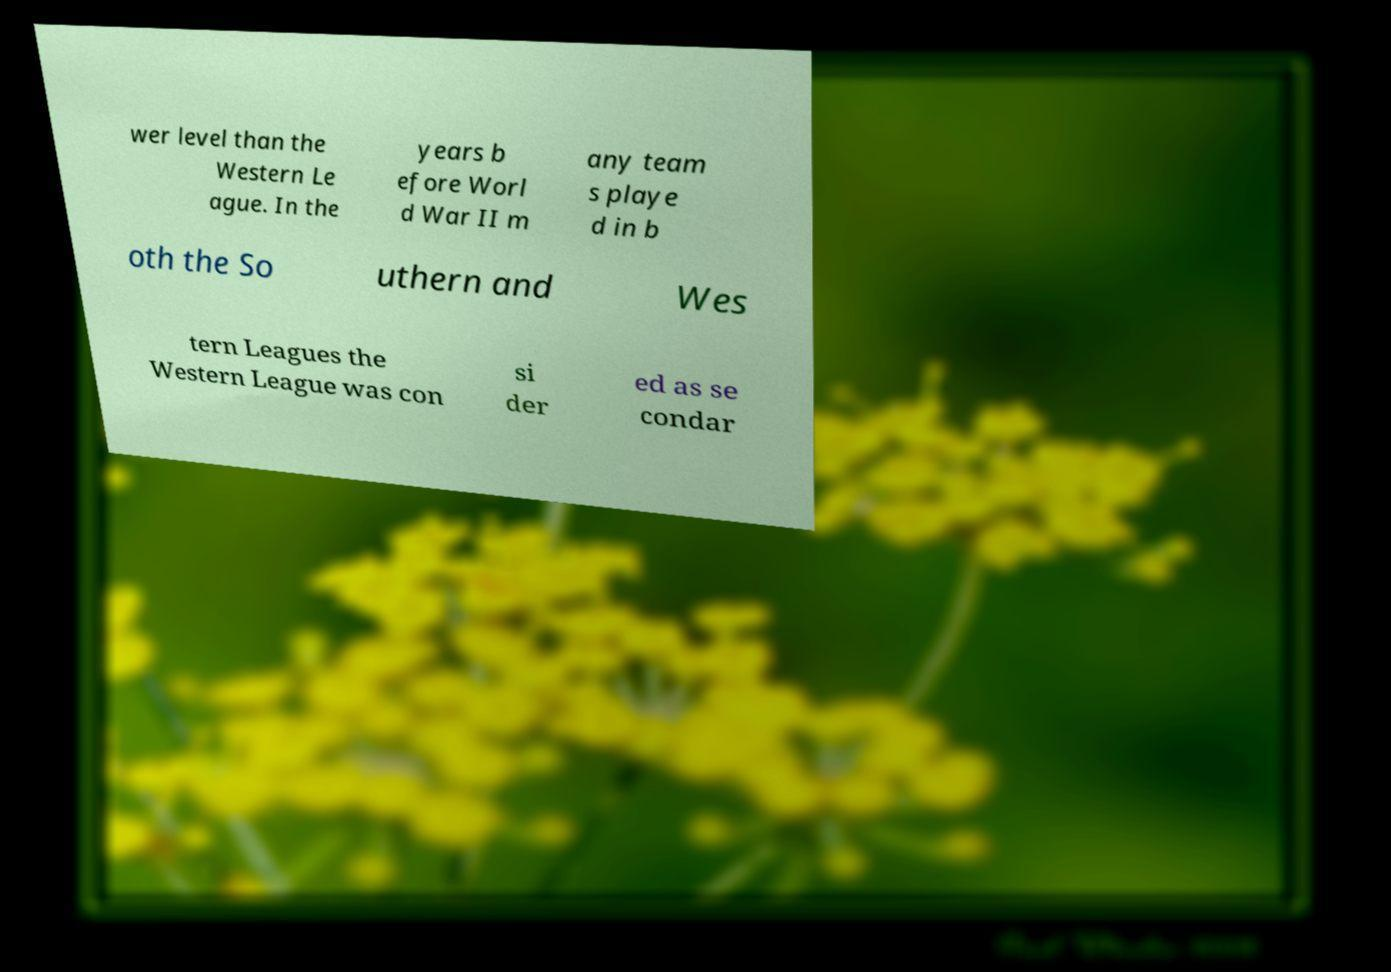For documentation purposes, I need the text within this image transcribed. Could you provide that? wer level than the Western Le ague. In the years b efore Worl d War II m any team s playe d in b oth the So uthern and Wes tern Leagues the Western League was con si der ed as se condar 